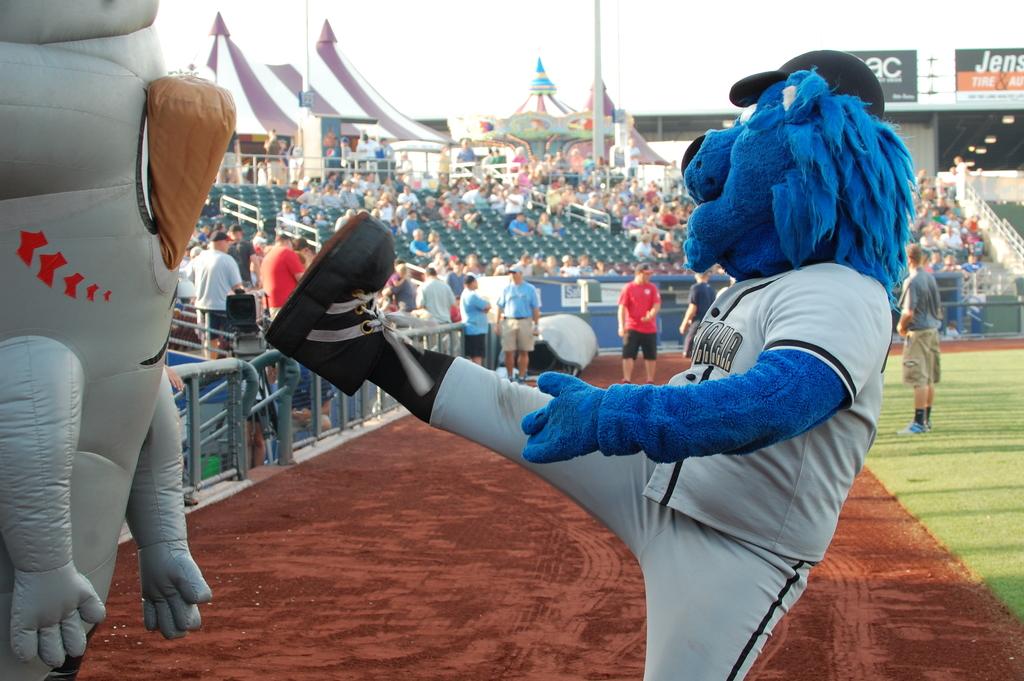What are the first 3 letters on the sign at the top right?
Ensure brevity in your answer.  Jen. 